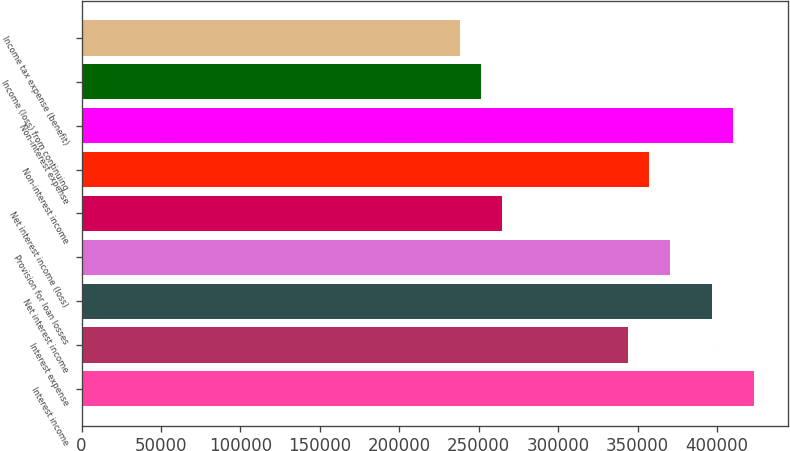Convert chart. <chart><loc_0><loc_0><loc_500><loc_500><bar_chart><fcel>Interest income<fcel>Interest expense<fcel>Net interest income<fcel>Provision for loan losses<fcel>Net interest income (loss)<fcel>Non-interest income<fcel>Non-interest expense<fcel>Income (loss) from continuing<fcel>Income tax expense (benefit)<nl><fcel>423523<fcel>344113<fcel>397053<fcel>370583<fcel>264702<fcel>357348<fcel>410288<fcel>251467<fcel>238232<nl></chart> 